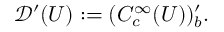<formula> <loc_0><loc_0><loc_500><loc_500>{ \mathcal { D } } ^ { \prime } ( U ) \colon = ( C _ { c } ^ { \infty } ( U ) ) _ { b } ^ { \prime } .</formula> 